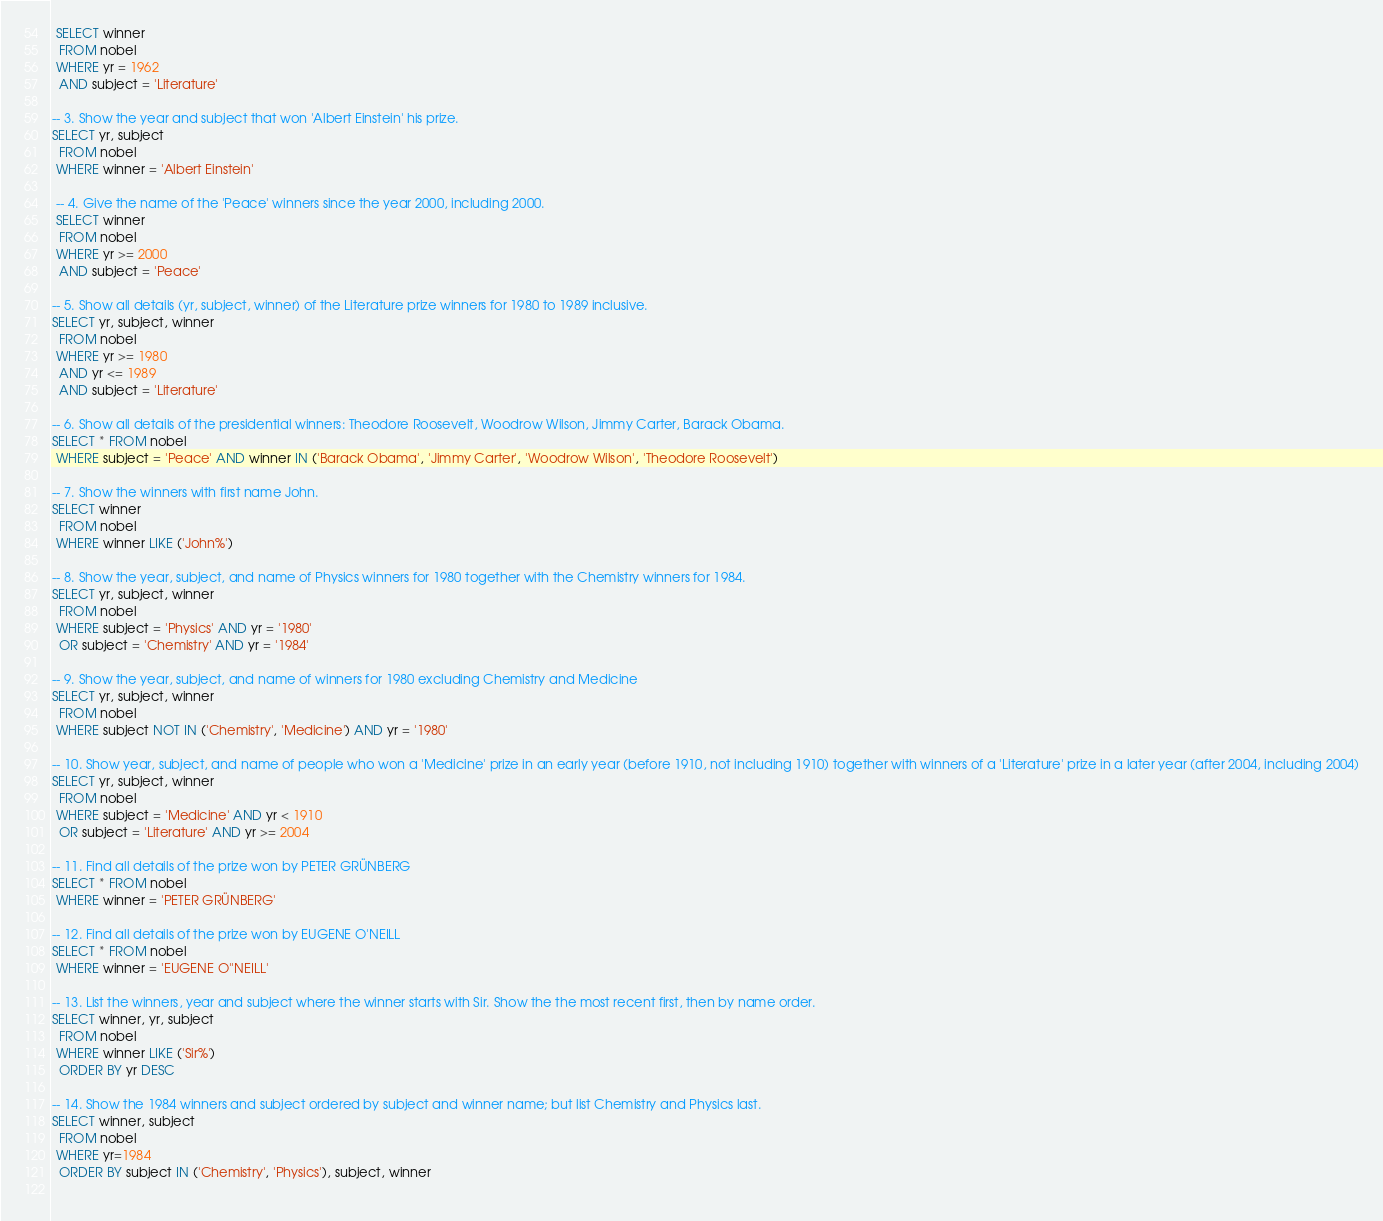<code> <loc_0><loc_0><loc_500><loc_500><_SQL_> SELECT winner
  FROM nobel
 WHERE yr = 1962
  AND subject = 'Literature'

-- 3. Show the year and subject that won 'Albert Einstein' his prize.
SELECT yr, subject
  FROM nobel
 WHERE winner = 'Albert Einstein'

 -- 4. Give the name of the 'Peace' winners since the year 2000, including 2000.
 SELECT winner 
  FROM nobel
 WHERE yr >= 2000 
  AND subject = 'Peace'

-- 5. Show all details (yr, subject, winner) of the Literature prize winners for 1980 to 1989 inclusive.
SELECT yr, subject, winner
  FROM nobel 
 WHERE yr >= 1980
  AND yr <= 1989 
  AND subject = 'Literature'

-- 6. Show all details of the presidential winners: Theodore Roosevelt, Woodrow Wilson, Jimmy Carter, Barack Obama.
SELECT * FROM nobel
 WHERE subject = 'Peace' AND winner IN ('Barack Obama', 'Jimmy Carter', 'Woodrow Wilson', 'Theodore Roosevelt')

-- 7. Show the winners with first name John.
SELECT winner
  FROM nobel 
 WHERE winner LIKE ('John%')

-- 8. Show the year, subject, and name of Physics winners for 1980 together with the Chemistry winners for 1984.
SELECT yr, subject, winner
  FROM nobel
 WHERE subject = 'Physics' AND yr = '1980'
  OR subject = 'Chemistry' AND yr = '1984'

-- 9. Show the year, subject, and name of winners for 1980 excluding Chemistry and Medicine
SELECT yr, subject, winner
  FROM nobel 
 WHERE subject NOT IN ('Chemistry', 'Medicine') AND yr = '1980'

-- 10. Show year, subject, and name of people who won a 'Medicine' prize in an early year (before 1910, not including 1910) together with winners of a 'Literature' prize in a later year (after 2004, including 2004)
SELECT yr, subject, winner
  FROM nobel
 WHERE subject = 'Medicine' AND yr < 1910
  OR subject = 'Literature' AND yr >= 2004

-- 11. Find all details of the prize won by PETER GRÜNBERG
SELECT * FROM nobel 
 WHERE winner = 'PETER GRÜNBERG'

-- 12. Find all details of the prize won by EUGENE O'NEILL
SELECT * FROM nobel
 WHERE winner = 'EUGENE O''NEILL'

-- 13. List the winners, year and subject where the winner starts with Sir. Show the the most recent first, then by name order.
SELECT winner, yr, subject
  FROM nobel 
 WHERE winner LIKE ('Sir%') 
  ORDER BY yr DESC

-- 14. Show the 1984 winners and subject ordered by subject and winner name; but list Chemistry and Physics last.
SELECT winner, subject
  FROM nobel
 WHERE yr=1984
  ORDER BY subject IN ('Chemistry', 'Physics'), subject, winner
  
</code> 